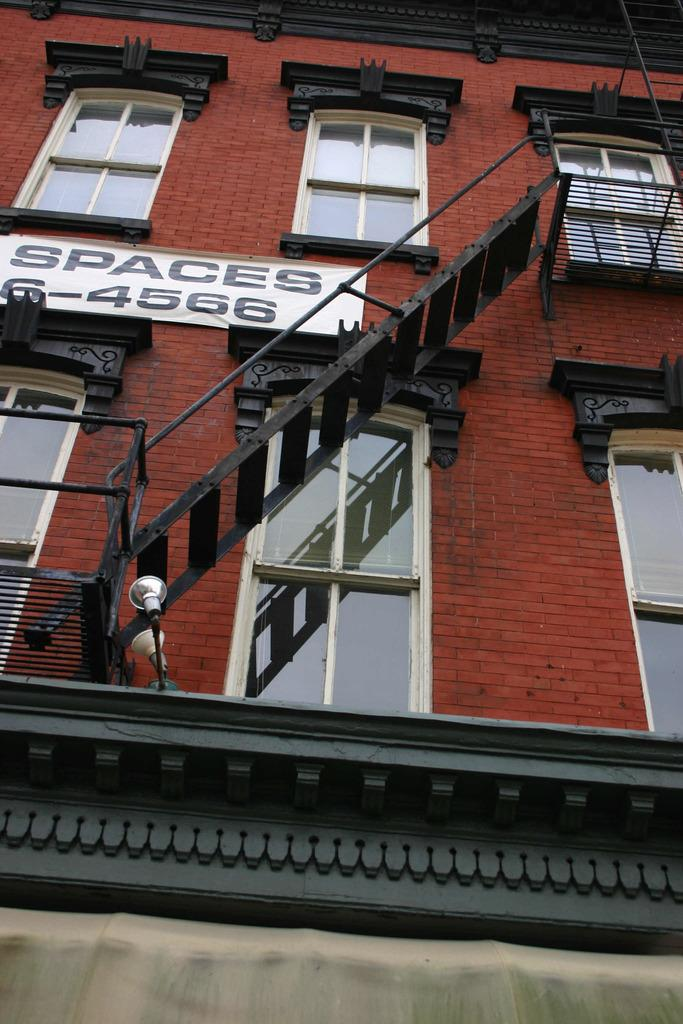What type of structure is visible in the image? There is a building in the image. What feature can be observed on the building? The building has glass windows. What is attached to a wall in the image? There is a ladder attached to a wall in the image. What is hanging on the brown color wall in the image? There is a banner attached to a brown color wall in the image. Can you see any cobwebs in the image? There is no mention of cobwebs in the provided facts, so we cannot determine if any are present in the image. What type of car is parked near the building in the image? There is no mention of a car in the provided facts, so we cannot determine if any are present in the image. 